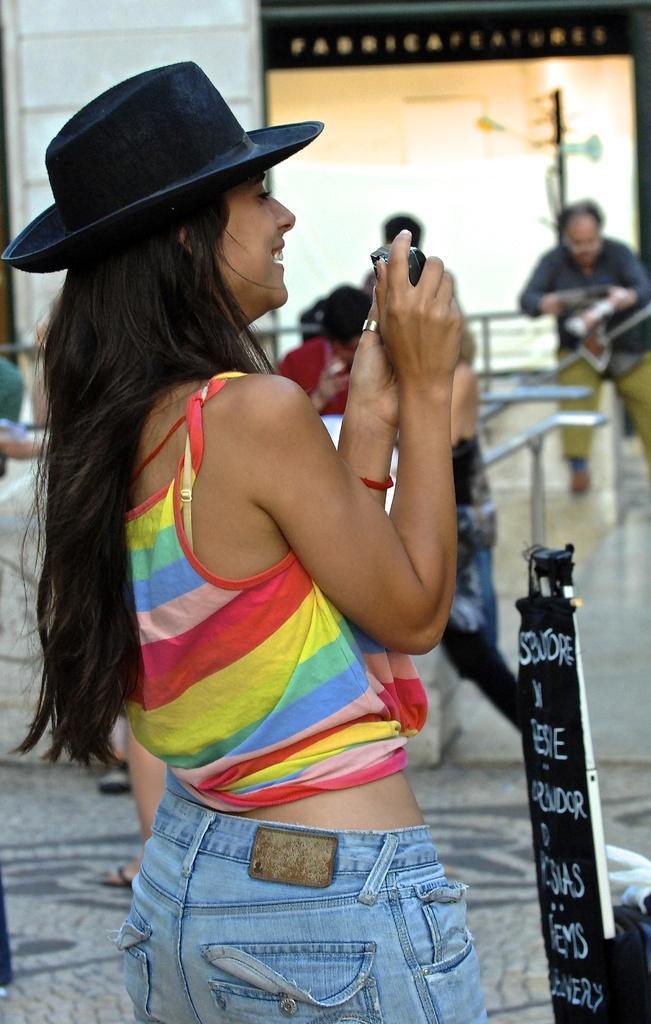Please provide a concise description of this image. In this image there is a woman with a hat is standing and holding a camera , and in the background there is a board, group of people, house, iron rods. 